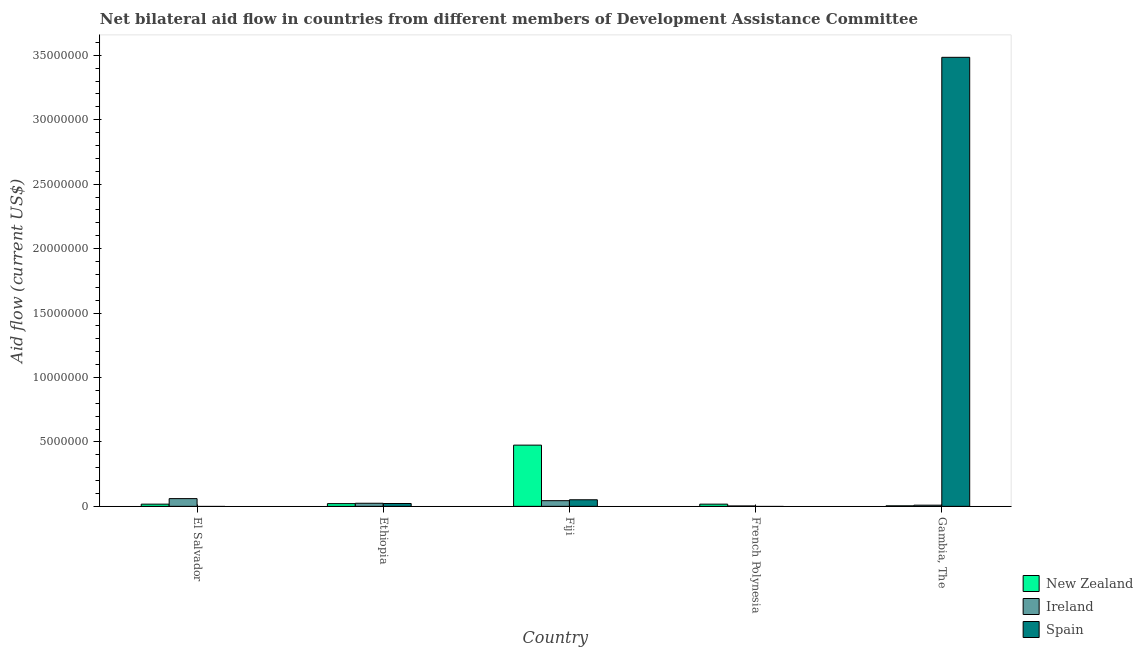How many groups of bars are there?
Ensure brevity in your answer.  5. Are the number of bars per tick equal to the number of legend labels?
Your response must be concise. No. How many bars are there on the 2nd tick from the left?
Your answer should be very brief. 3. How many bars are there on the 3rd tick from the right?
Your answer should be compact. 3. What is the label of the 2nd group of bars from the left?
Offer a very short reply. Ethiopia. In how many cases, is the number of bars for a given country not equal to the number of legend labels?
Keep it short and to the point. 2. What is the amount of aid provided by spain in Ethiopia?
Keep it short and to the point. 2.20e+05. Across all countries, what is the maximum amount of aid provided by ireland?
Offer a very short reply. 6.00e+05. Across all countries, what is the minimum amount of aid provided by ireland?
Your answer should be very brief. 3.00e+04. In which country was the amount of aid provided by new zealand maximum?
Keep it short and to the point. Fiji. What is the total amount of aid provided by new zealand in the graph?
Offer a terse response. 5.34e+06. What is the difference between the amount of aid provided by ireland in El Salvador and that in French Polynesia?
Your answer should be compact. 5.70e+05. What is the difference between the amount of aid provided by spain in Fiji and the amount of aid provided by ireland in El Salvador?
Ensure brevity in your answer.  -9.00e+04. What is the average amount of aid provided by ireland per country?
Ensure brevity in your answer.  2.80e+05. What is the difference between the amount of aid provided by spain and amount of aid provided by new zealand in Ethiopia?
Your response must be concise. 10000. What is the ratio of the amount of aid provided by new zealand in El Salvador to that in Gambia, The?
Keep it short and to the point. 4.25. Is the difference between the amount of aid provided by new zealand in Fiji and Gambia, The greater than the difference between the amount of aid provided by ireland in Fiji and Gambia, The?
Your answer should be very brief. Yes. What is the difference between the highest and the second highest amount of aid provided by spain?
Provide a short and direct response. 3.43e+07. What is the difference between the highest and the lowest amount of aid provided by ireland?
Provide a short and direct response. 5.70e+05. In how many countries, is the amount of aid provided by spain greater than the average amount of aid provided by spain taken over all countries?
Your answer should be very brief. 1. Is the sum of the amount of aid provided by new zealand in El Salvador and Fiji greater than the maximum amount of aid provided by ireland across all countries?
Your response must be concise. Yes. How many bars are there?
Make the answer very short. 13. Does the graph contain grids?
Ensure brevity in your answer.  No. How many legend labels are there?
Your response must be concise. 3. What is the title of the graph?
Your response must be concise. Net bilateral aid flow in countries from different members of Development Assistance Committee. What is the label or title of the Y-axis?
Offer a very short reply. Aid flow (current US$). What is the Aid flow (current US$) of Spain in Ethiopia?
Make the answer very short. 2.20e+05. What is the Aid flow (current US$) of New Zealand in Fiji?
Make the answer very short. 4.75e+06. What is the Aid flow (current US$) of Spain in Fiji?
Provide a short and direct response. 5.10e+05. What is the Aid flow (current US$) in New Zealand in French Polynesia?
Your answer should be compact. 1.70e+05. What is the Aid flow (current US$) of Spain in French Polynesia?
Your answer should be compact. 0. What is the Aid flow (current US$) in New Zealand in Gambia, The?
Keep it short and to the point. 4.00e+04. What is the Aid flow (current US$) of Ireland in Gambia, The?
Provide a succinct answer. 9.00e+04. What is the Aid flow (current US$) in Spain in Gambia, The?
Give a very brief answer. 3.48e+07. Across all countries, what is the maximum Aid flow (current US$) of New Zealand?
Offer a very short reply. 4.75e+06. Across all countries, what is the maximum Aid flow (current US$) in Ireland?
Offer a very short reply. 6.00e+05. Across all countries, what is the maximum Aid flow (current US$) of Spain?
Your answer should be very brief. 3.48e+07. What is the total Aid flow (current US$) in New Zealand in the graph?
Give a very brief answer. 5.34e+06. What is the total Aid flow (current US$) of Ireland in the graph?
Your response must be concise. 1.40e+06. What is the total Aid flow (current US$) of Spain in the graph?
Ensure brevity in your answer.  3.56e+07. What is the difference between the Aid flow (current US$) in New Zealand in El Salvador and that in Fiji?
Your answer should be very brief. -4.58e+06. What is the difference between the Aid flow (current US$) in New Zealand in El Salvador and that in French Polynesia?
Keep it short and to the point. 0. What is the difference between the Aid flow (current US$) of Ireland in El Salvador and that in French Polynesia?
Provide a succinct answer. 5.70e+05. What is the difference between the Aid flow (current US$) of Ireland in El Salvador and that in Gambia, The?
Provide a succinct answer. 5.10e+05. What is the difference between the Aid flow (current US$) of New Zealand in Ethiopia and that in Fiji?
Your response must be concise. -4.54e+06. What is the difference between the Aid flow (current US$) in Ireland in Ethiopia and that in Fiji?
Give a very brief answer. -2.00e+05. What is the difference between the Aid flow (current US$) of Spain in Ethiopia and that in Fiji?
Provide a succinct answer. -2.90e+05. What is the difference between the Aid flow (current US$) in New Zealand in Ethiopia and that in French Polynesia?
Your answer should be compact. 4.00e+04. What is the difference between the Aid flow (current US$) in Ireland in Ethiopia and that in French Polynesia?
Provide a short and direct response. 2.10e+05. What is the difference between the Aid flow (current US$) of New Zealand in Ethiopia and that in Gambia, The?
Make the answer very short. 1.70e+05. What is the difference between the Aid flow (current US$) of Spain in Ethiopia and that in Gambia, The?
Offer a terse response. -3.46e+07. What is the difference between the Aid flow (current US$) of New Zealand in Fiji and that in French Polynesia?
Ensure brevity in your answer.  4.58e+06. What is the difference between the Aid flow (current US$) of Ireland in Fiji and that in French Polynesia?
Offer a terse response. 4.10e+05. What is the difference between the Aid flow (current US$) in New Zealand in Fiji and that in Gambia, The?
Provide a succinct answer. 4.71e+06. What is the difference between the Aid flow (current US$) in Spain in Fiji and that in Gambia, The?
Make the answer very short. -3.43e+07. What is the difference between the Aid flow (current US$) of New Zealand in El Salvador and the Aid flow (current US$) of Ireland in Ethiopia?
Provide a succinct answer. -7.00e+04. What is the difference between the Aid flow (current US$) of Ireland in El Salvador and the Aid flow (current US$) of Spain in Ethiopia?
Provide a succinct answer. 3.80e+05. What is the difference between the Aid flow (current US$) of New Zealand in El Salvador and the Aid flow (current US$) of Spain in Fiji?
Your answer should be compact. -3.40e+05. What is the difference between the Aid flow (current US$) of New Zealand in El Salvador and the Aid flow (current US$) of Ireland in French Polynesia?
Your response must be concise. 1.40e+05. What is the difference between the Aid flow (current US$) of New Zealand in El Salvador and the Aid flow (current US$) of Spain in Gambia, The?
Offer a very short reply. -3.47e+07. What is the difference between the Aid flow (current US$) in Ireland in El Salvador and the Aid flow (current US$) in Spain in Gambia, The?
Ensure brevity in your answer.  -3.42e+07. What is the difference between the Aid flow (current US$) of New Zealand in Ethiopia and the Aid flow (current US$) of Ireland in Fiji?
Provide a succinct answer. -2.30e+05. What is the difference between the Aid flow (current US$) of Ireland in Ethiopia and the Aid flow (current US$) of Spain in Fiji?
Give a very brief answer. -2.70e+05. What is the difference between the Aid flow (current US$) of New Zealand in Ethiopia and the Aid flow (current US$) of Ireland in Gambia, The?
Your answer should be very brief. 1.20e+05. What is the difference between the Aid flow (current US$) of New Zealand in Ethiopia and the Aid flow (current US$) of Spain in Gambia, The?
Provide a short and direct response. -3.46e+07. What is the difference between the Aid flow (current US$) of Ireland in Ethiopia and the Aid flow (current US$) of Spain in Gambia, The?
Keep it short and to the point. -3.46e+07. What is the difference between the Aid flow (current US$) of New Zealand in Fiji and the Aid flow (current US$) of Ireland in French Polynesia?
Offer a terse response. 4.72e+06. What is the difference between the Aid flow (current US$) in New Zealand in Fiji and the Aid flow (current US$) in Ireland in Gambia, The?
Offer a terse response. 4.66e+06. What is the difference between the Aid flow (current US$) in New Zealand in Fiji and the Aid flow (current US$) in Spain in Gambia, The?
Make the answer very short. -3.01e+07. What is the difference between the Aid flow (current US$) of Ireland in Fiji and the Aid flow (current US$) of Spain in Gambia, The?
Make the answer very short. -3.44e+07. What is the difference between the Aid flow (current US$) of New Zealand in French Polynesia and the Aid flow (current US$) of Ireland in Gambia, The?
Offer a terse response. 8.00e+04. What is the difference between the Aid flow (current US$) in New Zealand in French Polynesia and the Aid flow (current US$) in Spain in Gambia, The?
Provide a short and direct response. -3.47e+07. What is the difference between the Aid flow (current US$) of Ireland in French Polynesia and the Aid flow (current US$) of Spain in Gambia, The?
Your answer should be compact. -3.48e+07. What is the average Aid flow (current US$) of New Zealand per country?
Your answer should be very brief. 1.07e+06. What is the average Aid flow (current US$) of Ireland per country?
Give a very brief answer. 2.80e+05. What is the average Aid flow (current US$) of Spain per country?
Offer a terse response. 7.11e+06. What is the difference between the Aid flow (current US$) of New Zealand and Aid flow (current US$) of Ireland in El Salvador?
Make the answer very short. -4.30e+05. What is the difference between the Aid flow (current US$) of New Zealand and Aid flow (current US$) of Ireland in Fiji?
Your answer should be compact. 4.31e+06. What is the difference between the Aid flow (current US$) in New Zealand and Aid flow (current US$) in Spain in Fiji?
Your answer should be compact. 4.24e+06. What is the difference between the Aid flow (current US$) of Ireland and Aid flow (current US$) of Spain in Fiji?
Your answer should be compact. -7.00e+04. What is the difference between the Aid flow (current US$) of New Zealand and Aid flow (current US$) of Ireland in Gambia, The?
Make the answer very short. -5.00e+04. What is the difference between the Aid flow (current US$) of New Zealand and Aid flow (current US$) of Spain in Gambia, The?
Your answer should be compact. -3.48e+07. What is the difference between the Aid flow (current US$) of Ireland and Aid flow (current US$) of Spain in Gambia, The?
Ensure brevity in your answer.  -3.48e+07. What is the ratio of the Aid flow (current US$) in New Zealand in El Salvador to that in Ethiopia?
Keep it short and to the point. 0.81. What is the ratio of the Aid flow (current US$) in New Zealand in El Salvador to that in Fiji?
Provide a succinct answer. 0.04. What is the ratio of the Aid flow (current US$) of Ireland in El Salvador to that in Fiji?
Keep it short and to the point. 1.36. What is the ratio of the Aid flow (current US$) in Ireland in El Salvador to that in French Polynesia?
Keep it short and to the point. 20. What is the ratio of the Aid flow (current US$) in New Zealand in El Salvador to that in Gambia, The?
Offer a very short reply. 4.25. What is the ratio of the Aid flow (current US$) in Ireland in El Salvador to that in Gambia, The?
Keep it short and to the point. 6.67. What is the ratio of the Aid flow (current US$) of New Zealand in Ethiopia to that in Fiji?
Provide a succinct answer. 0.04. What is the ratio of the Aid flow (current US$) in Ireland in Ethiopia to that in Fiji?
Your response must be concise. 0.55. What is the ratio of the Aid flow (current US$) in Spain in Ethiopia to that in Fiji?
Offer a terse response. 0.43. What is the ratio of the Aid flow (current US$) in New Zealand in Ethiopia to that in French Polynesia?
Make the answer very short. 1.24. What is the ratio of the Aid flow (current US$) in Ireland in Ethiopia to that in French Polynesia?
Ensure brevity in your answer.  8. What is the ratio of the Aid flow (current US$) in New Zealand in Ethiopia to that in Gambia, The?
Offer a very short reply. 5.25. What is the ratio of the Aid flow (current US$) in Ireland in Ethiopia to that in Gambia, The?
Offer a very short reply. 2.67. What is the ratio of the Aid flow (current US$) in Spain in Ethiopia to that in Gambia, The?
Keep it short and to the point. 0.01. What is the ratio of the Aid flow (current US$) in New Zealand in Fiji to that in French Polynesia?
Make the answer very short. 27.94. What is the ratio of the Aid flow (current US$) of Ireland in Fiji to that in French Polynesia?
Make the answer very short. 14.67. What is the ratio of the Aid flow (current US$) of New Zealand in Fiji to that in Gambia, The?
Provide a short and direct response. 118.75. What is the ratio of the Aid flow (current US$) in Ireland in Fiji to that in Gambia, The?
Offer a very short reply. 4.89. What is the ratio of the Aid flow (current US$) in Spain in Fiji to that in Gambia, The?
Your answer should be very brief. 0.01. What is the ratio of the Aid flow (current US$) of New Zealand in French Polynesia to that in Gambia, The?
Provide a succinct answer. 4.25. What is the difference between the highest and the second highest Aid flow (current US$) in New Zealand?
Offer a very short reply. 4.54e+06. What is the difference between the highest and the second highest Aid flow (current US$) in Spain?
Keep it short and to the point. 3.43e+07. What is the difference between the highest and the lowest Aid flow (current US$) of New Zealand?
Offer a very short reply. 4.71e+06. What is the difference between the highest and the lowest Aid flow (current US$) of Ireland?
Keep it short and to the point. 5.70e+05. What is the difference between the highest and the lowest Aid flow (current US$) in Spain?
Your response must be concise. 3.48e+07. 